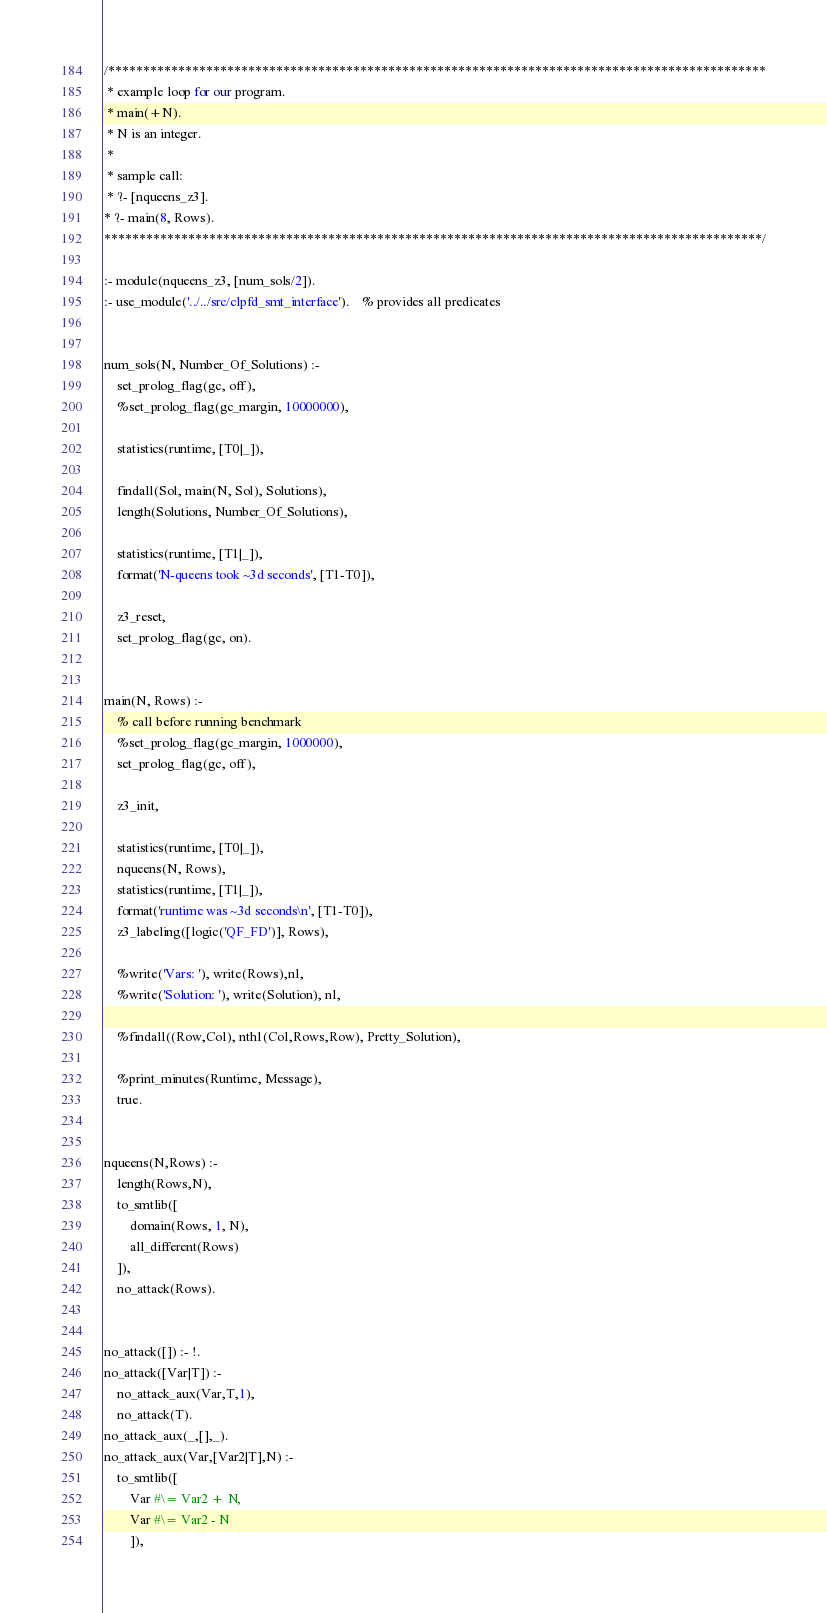Convert code to text. <code><loc_0><loc_0><loc_500><loc_500><_Perl_>/**********************************************************************************************
 * example loop for our program. 
 * main(+N). 
 * N is an integer. 
 * 
 * sample call:
 * ?- [nqueens_z3].
* ?- main(8, Rows).
**********************************************************************************************/

:- module(nqueens_z3, [num_sols/2]).
:- use_module('../../src/clpfd_smt_interface').    % provides all predicates


num_sols(N, Number_Of_Solutions) :-
    set_prolog_flag(gc, off),
    %set_prolog_flag(gc_margin, 10000000),
    
    statistics(runtime, [T0|_]),

    findall(Sol, main(N, Sol), Solutions),
    length(Solutions, Number_Of_Solutions),
    
    statistics(runtime, [T1|_]),
    format('N-queens took ~3d seconds', [T1-T0]),

    z3_reset,
    set_prolog_flag(gc, on).


main(N, Rows) :-
    % call before running benchmark
    %set_prolog_flag(gc_margin, 1000000),
    set_prolog_flag(gc, off),

    z3_init,

    statistics(runtime, [T0|_]),
    nqueens(N, Rows),
    statistics(runtime, [T1|_]),
    format('runtime was ~3d seconds\n', [T1-T0]),
    z3_labeling([logic('QF_FD')], Rows),

    %write('Vars: '), write(Rows),nl,
    %write('Solution: '), write(Solution), nl,

    %findall((Row,Col), nth1(Col,Rows,Row), Pretty_Solution),
    
    %print_minutes(Runtime, Message),
    true.


nqueens(N,Rows) :-
    length(Rows,N),
    to_smtlib([
        domain(Rows, 1, N), 
        all_different(Rows)
    ]),
    no_attack(Rows).


no_attack([]) :- !.
no_attack([Var|T]) :-
    no_attack_aux(Var,T,1),
    no_attack(T).
no_attack_aux(_,[],_).
no_attack_aux(Var,[Var2|T],N) :-
    to_smtlib([
        Var #\= Var2 + N, 
        Var #\= Var2 - N
        ]),</code> 